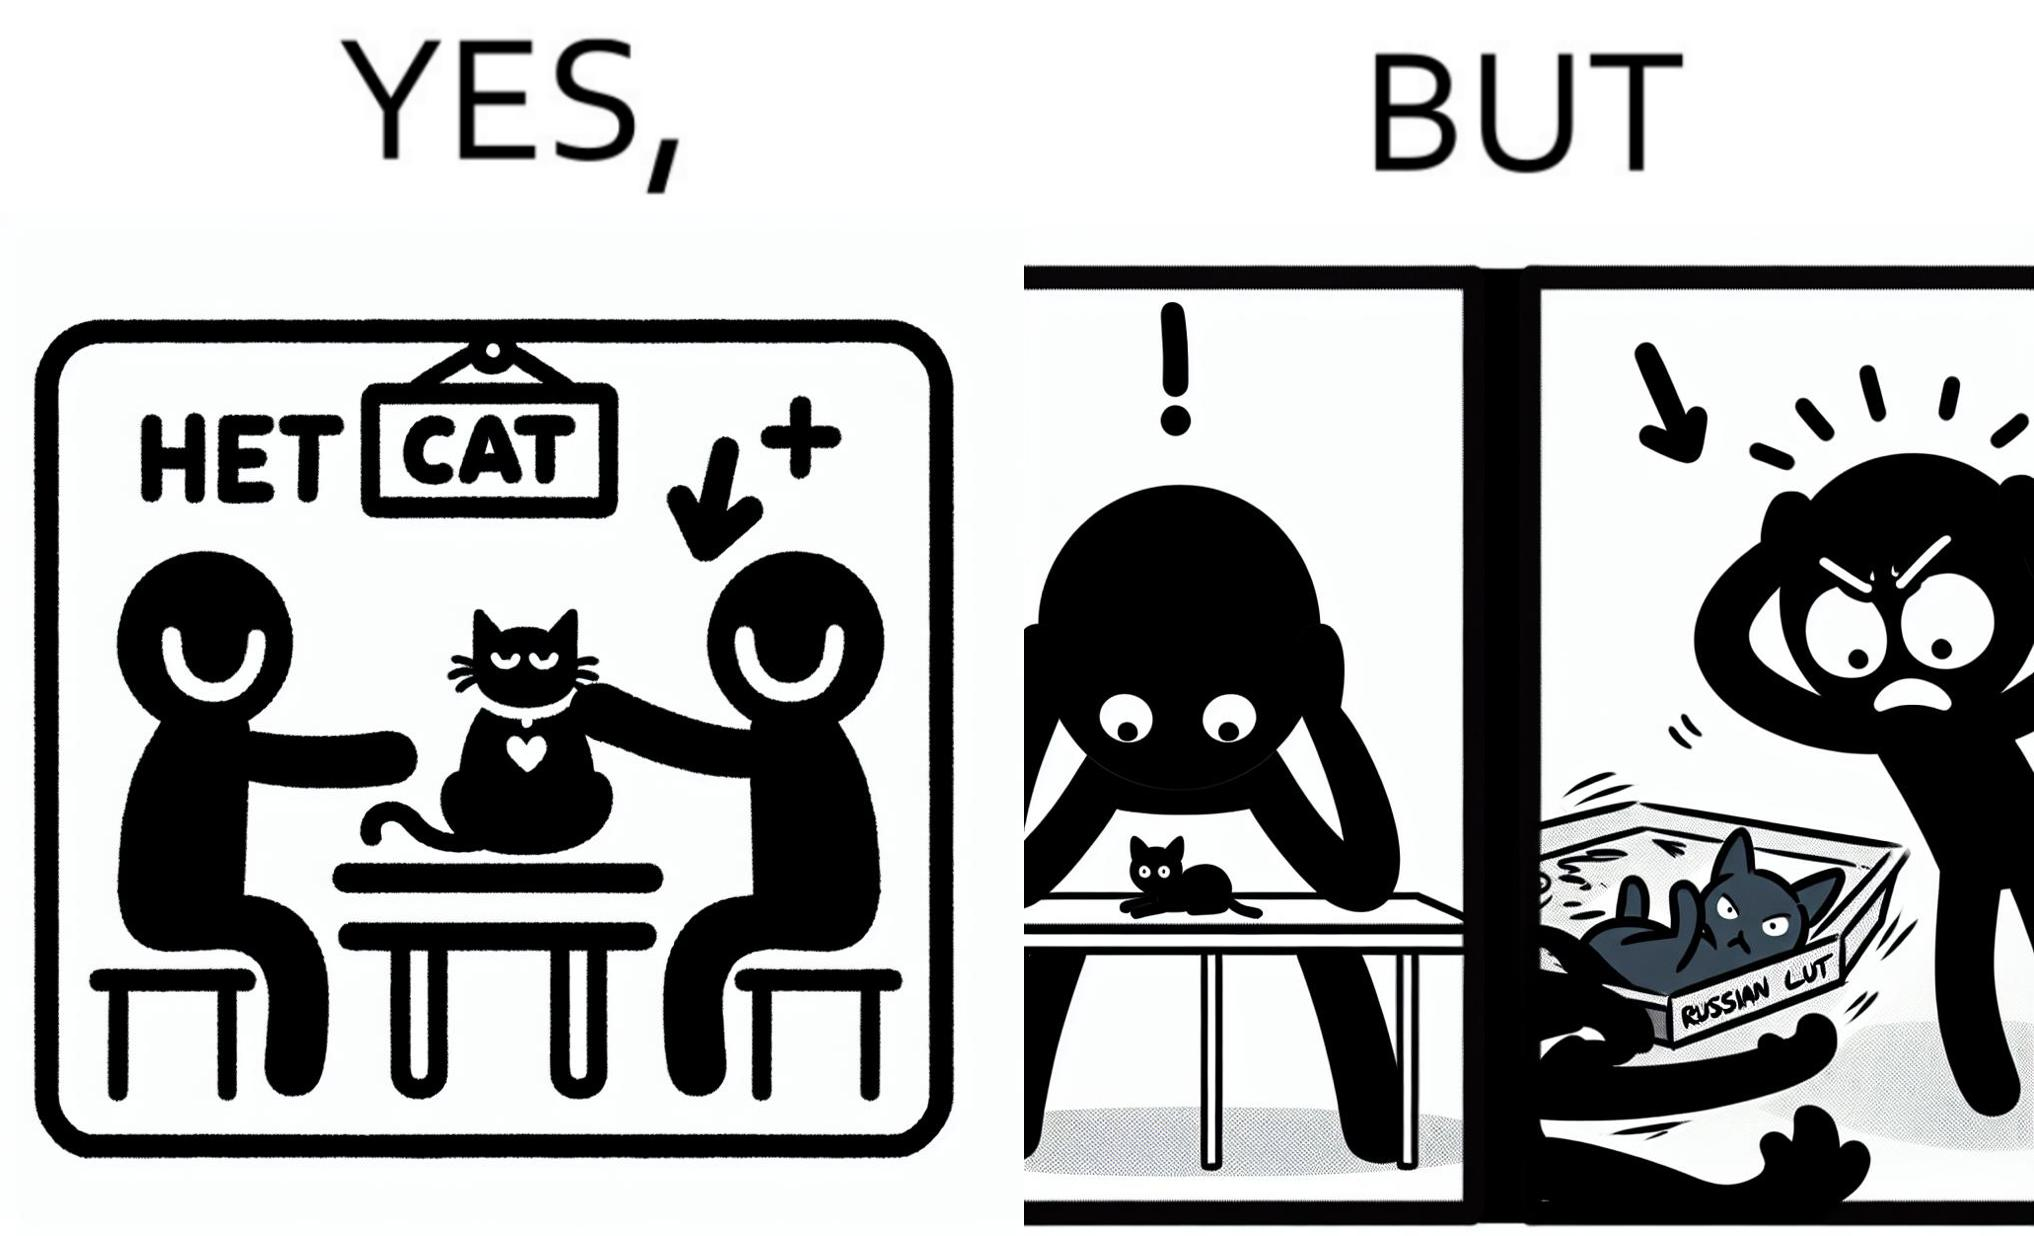What makes this image funny or satirical? The image is confusing, as initially, when the label reads "Blue Cat", the people are happy and are petting tha cat, but as soon as one of them realizes that the entire text reads "Russian Blue Cat", they seem to worried, and one of them throws away the cat. For some reason, the word "Russian" is a trigger word for them. 